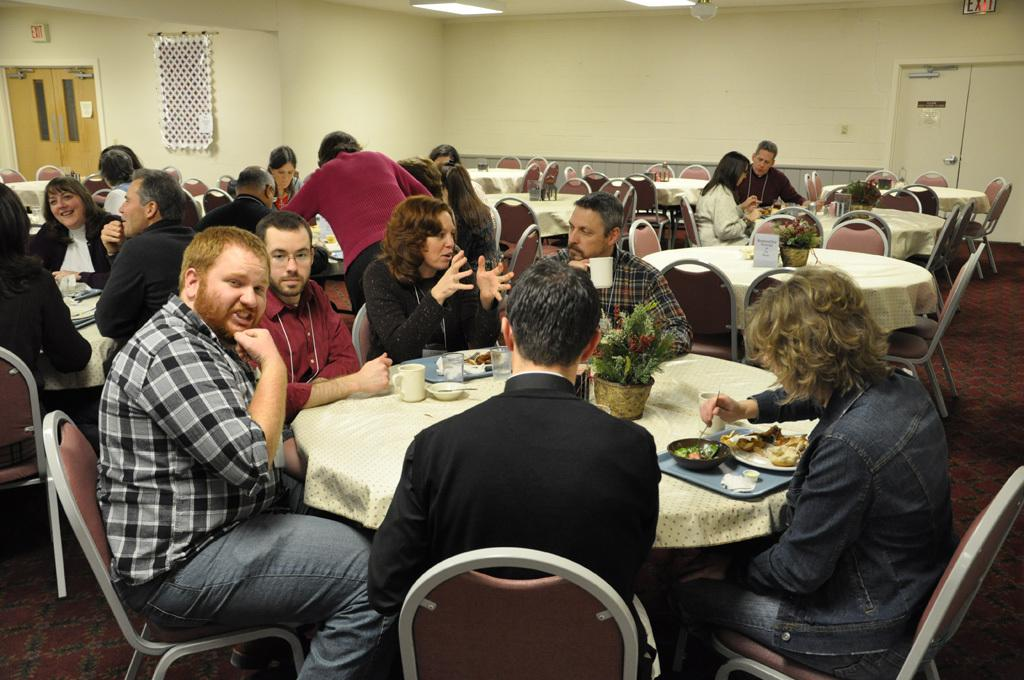What is one of the main features of the image? There is a door in the image. What color is the wall in the image? The wall is yellow in color. What are the people in the image doing? There are people sitting on chairs in the image. What is on the table in the image? On the table, there is a plate, a bowl, a spoon, a glass, and a cup. What event is taking place in the image? There is no specific event taking place in the image; it simply shows a door, a yellow wall, people sitting on chairs, and items on a table. How does the limit of the table affect the number of items that can be placed on it? The image does not provide information about the limit of the table, so it is not possible to determine how the limit affects the number of items that can be placed on it. 